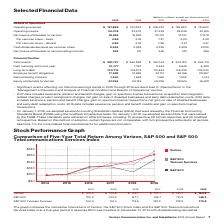According to Verizon Communications's financial document, What was the operating revenue in 2019? According to the financial document, $131,868 (in millions). The relevant text states: "Operating revenues $ 131,868 $ 130,863 $ 126,034 $ 125,980 $ 131,620..." Also, What was the Per common share – basic in 2019? According to the financial document, 4.66. The relevant text states: "Per common share – basic 4.66 3.76 7.37 3.22 4.38..." Also, What was the Total assets in 2019? According to the financial document, $ 291,727 (in millions). The relevant text states: "Total assets $ 291,727 $ 264,829 $ 257,143 $ 244,180 $ 244,175..." Also, can you calculate: What was the change in operating revenues from 2017 to 2018? Based on the calculation: 130,863 - 126,034, the result is 4829 (in millions). This is based on the information: "Operating revenues $ 131,868 $ 130,863 $ 126,034 $ 125,980 $ 131,620 Operating revenues $ 131,868 $ 130,863 $ 126,034 $ 125,980 $ 131,620..." The key data points involved are: 126,034, 130,863. Also, can you calculate: What was the average operating income for 2015-2019? To answer this question, I need to perform calculations using the financial data. The calculation is: (30,378 + 22,278 + 27,425 + 29,249 + 30,615) / 5, which equals 27989 (in millions). This is based on the information: "Operating income 30,378 22,278 27,425 29,249 30,615 Operating income 30,378 22,278 27,425 29,249 30,615 Operating income 30,378 22,278 27,425 29,249 30,615 Operating income 30,378 22,278 27,425 29,249..." The key data points involved are: 22,278, 27,425, 29,249. Also, can you calculate: What was the change in the Per common share – basic from 2018 to 2019? Based on the calculation: 4.66 - 3.76, the result is 0.9. This is based on the information: "Per common share – basic 4.66 3.76 7.37 3.22 4.38 Per common share – basic 4.66 3.76 7.37 3.22 4.38..." The key data points involved are: 3.76, 4.66. 